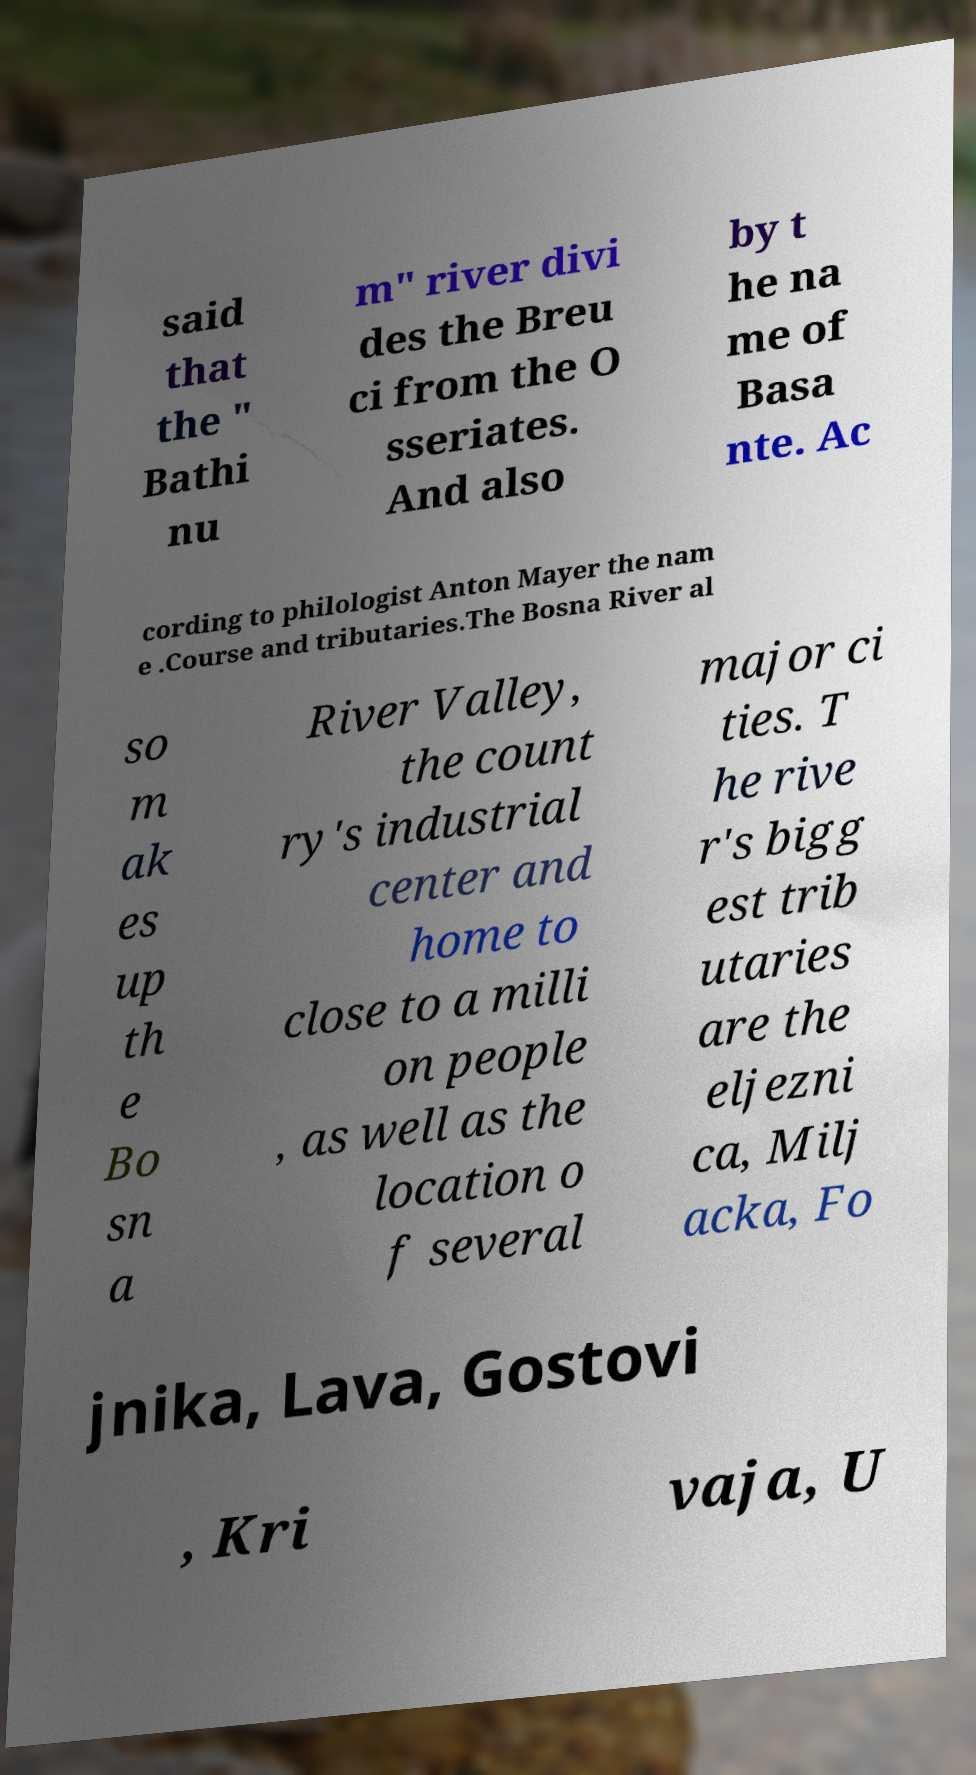There's text embedded in this image that I need extracted. Can you transcribe it verbatim? said that the " Bathi nu m" river divi des the Breu ci from the O sseriates. And also by t he na me of Basa nte. Ac cording to philologist Anton Mayer the nam e .Course and tributaries.The Bosna River al so m ak es up th e Bo sn a River Valley, the count ry's industrial center and home to close to a milli on people , as well as the location o f several major ci ties. T he rive r's bigg est trib utaries are the eljezni ca, Milj acka, Fo jnika, Lava, Gostovi , Kri vaja, U 